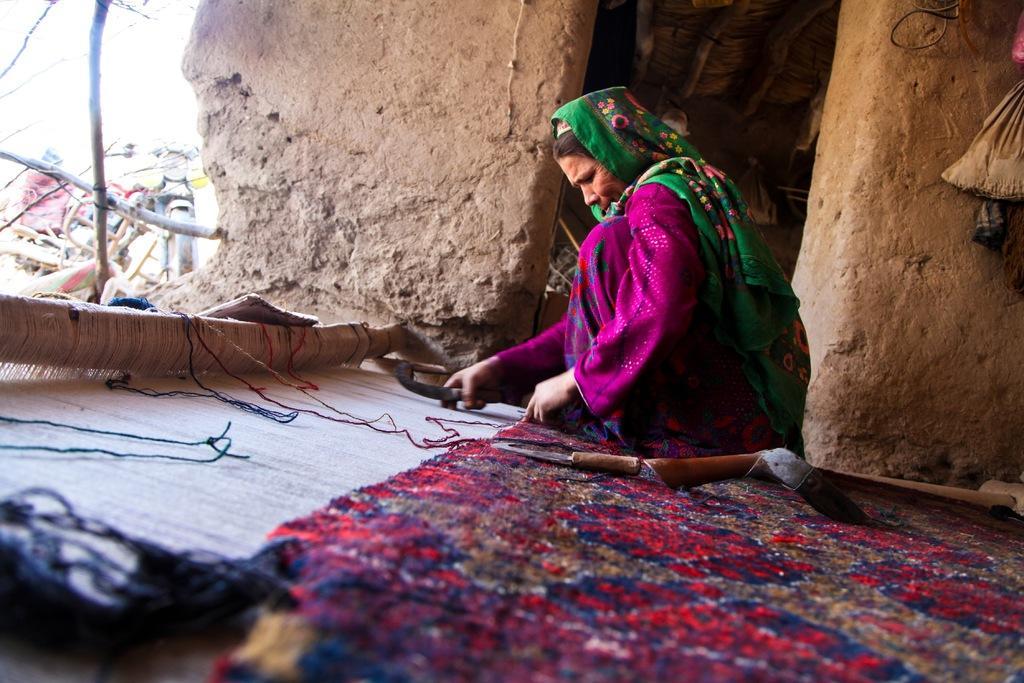Please provide a concise description of this image. In this image in the center there is one woman who is sitting and she is holding something in her hand, at the bottom there is a carpet and some threads and one object. In the background there is a house, and in the house there are some objects and on the left side there is one bike, wooden poles and some objects. 